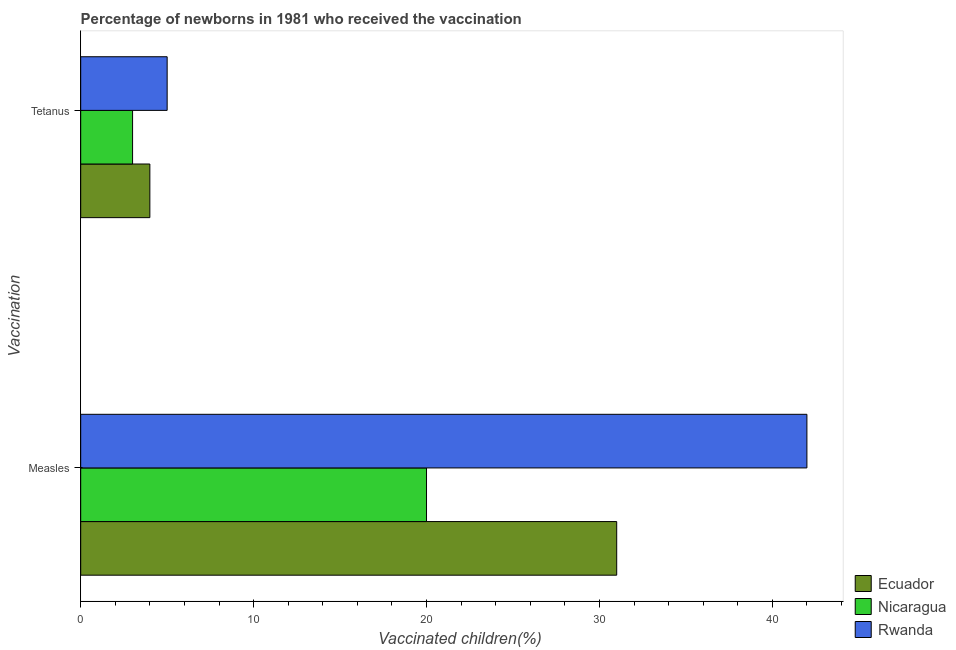How many different coloured bars are there?
Offer a terse response. 3. Are the number of bars on each tick of the Y-axis equal?
Make the answer very short. Yes. What is the label of the 2nd group of bars from the top?
Your answer should be compact. Measles. What is the percentage of newborns who received vaccination for measles in Rwanda?
Offer a very short reply. 42. Across all countries, what is the maximum percentage of newborns who received vaccination for measles?
Your answer should be compact. 42. Across all countries, what is the minimum percentage of newborns who received vaccination for tetanus?
Make the answer very short. 3. In which country was the percentage of newborns who received vaccination for measles maximum?
Keep it short and to the point. Rwanda. In which country was the percentage of newborns who received vaccination for measles minimum?
Make the answer very short. Nicaragua. What is the total percentage of newborns who received vaccination for measles in the graph?
Make the answer very short. 93. What is the difference between the percentage of newborns who received vaccination for tetanus in Rwanda and that in Nicaragua?
Keep it short and to the point. 2. What is the difference between the percentage of newborns who received vaccination for tetanus in Ecuador and the percentage of newborns who received vaccination for measles in Rwanda?
Provide a succinct answer. -38. What is the difference between the percentage of newborns who received vaccination for measles and percentage of newborns who received vaccination for tetanus in Ecuador?
Your response must be concise. 27. What is the ratio of the percentage of newborns who received vaccination for measles in Ecuador to that in Rwanda?
Your answer should be very brief. 0.74. Is the percentage of newborns who received vaccination for measles in Nicaragua less than that in Ecuador?
Give a very brief answer. Yes. What does the 2nd bar from the top in Tetanus represents?
Make the answer very short. Nicaragua. What does the 2nd bar from the bottom in Measles represents?
Ensure brevity in your answer.  Nicaragua. Are all the bars in the graph horizontal?
Ensure brevity in your answer.  Yes. How many countries are there in the graph?
Offer a very short reply. 3. Does the graph contain grids?
Offer a terse response. No. Where does the legend appear in the graph?
Your answer should be very brief. Bottom right. How many legend labels are there?
Provide a succinct answer. 3. What is the title of the graph?
Provide a succinct answer. Percentage of newborns in 1981 who received the vaccination. What is the label or title of the X-axis?
Your answer should be compact. Vaccinated children(%)
. What is the label or title of the Y-axis?
Provide a succinct answer. Vaccination. What is the Vaccinated children(%)
 of Ecuador in Measles?
Offer a very short reply. 31. What is the Vaccinated children(%)
 of Rwanda in Measles?
Ensure brevity in your answer.  42. What is the Vaccinated children(%)
 in Ecuador in Tetanus?
Your answer should be compact. 4. What is the Vaccinated children(%)
 in Rwanda in Tetanus?
Provide a succinct answer. 5. Across all Vaccination, what is the maximum Vaccinated children(%)
 in Rwanda?
Your response must be concise. 42. Across all Vaccination, what is the minimum Vaccinated children(%)
 of Ecuador?
Ensure brevity in your answer.  4. Across all Vaccination, what is the minimum Vaccinated children(%)
 in Nicaragua?
Give a very brief answer. 3. Across all Vaccination, what is the minimum Vaccinated children(%)
 of Rwanda?
Offer a terse response. 5. What is the total Vaccinated children(%)
 in Ecuador in the graph?
Your answer should be very brief. 35. What is the difference between the Vaccinated children(%)
 in Nicaragua in Measles and that in Tetanus?
Ensure brevity in your answer.  17. What is the difference between the Vaccinated children(%)
 of Rwanda in Measles and that in Tetanus?
Offer a very short reply. 37. What is the average Vaccinated children(%)
 of Rwanda per Vaccination?
Your response must be concise. 23.5. What is the difference between the Vaccinated children(%)
 in Nicaragua and Vaccinated children(%)
 in Rwanda in Measles?
Provide a short and direct response. -22. What is the difference between the Vaccinated children(%)
 of Ecuador and Vaccinated children(%)
 of Nicaragua in Tetanus?
Provide a succinct answer. 1. What is the ratio of the Vaccinated children(%)
 in Ecuador in Measles to that in Tetanus?
Ensure brevity in your answer.  7.75. What is the ratio of the Vaccinated children(%)
 of Rwanda in Measles to that in Tetanus?
Make the answer very short. 8.4. What is the difference between the highest and the lowest Vaccinated children(%)
 in Nicaragua?
Your answer should be compact. 17. 